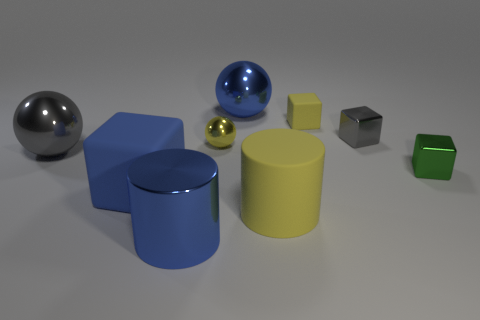What number of large blue blocks are made of the same material as the blue cylinder?
Provide a short and direct response. 0. What is the color of the big cylinder that is the same material as the green block?
Your answer should be very brief. Blue. What material is the large ball in front of the yellow rubber thing behind the small shiny cube that is on the right side of the tiny gray metallic cube?
Provide a succinct answer. Metal. There is a gray thing that is in front of the gray metal block; does it have the same size as the tiny gray cube?
Give a very brief answer. No. What number of large things are metallic cylinders or matte cubes?
Provide a short and direct response. 2. Are there any cylinders of the same color as the large rubber cube?
Your answer should be very brief. Yes. What is the shape of the yellow thing that is the same size as the blue sphere?
Offer a very short reply. Cylinder. Do the cylinder left of the blue metallic sphere and the small rubber object have the same color?
Keep it short and to the point. No. What number of objects are either tiny yellow things that are behind the small yellow ball or blue cubes?
Your answer should be compact. 2. Is the number of blue metal things on the left side of the small ball greater than the number of blue cylinders behind the tiny matte block?
Provide a succinct answer. Yes. 